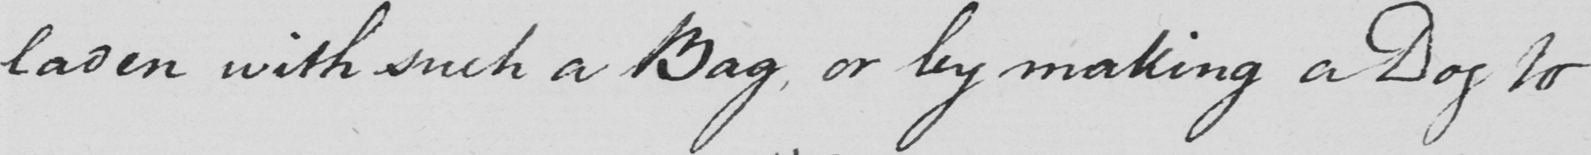What text is written in this handwritten line? laden with such a Bag , or by making a Dog to 